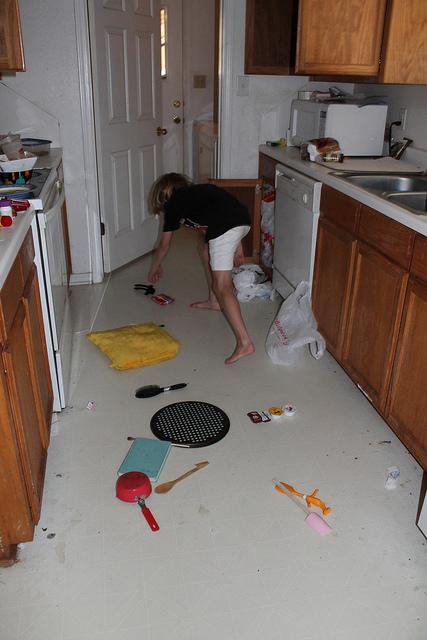Is the room tidy?
Short answer required. No. What are the cabinets made of?
Quick response, please. Wood. Has there been an accident in the kitchen?
Answer briefly. Yes. 